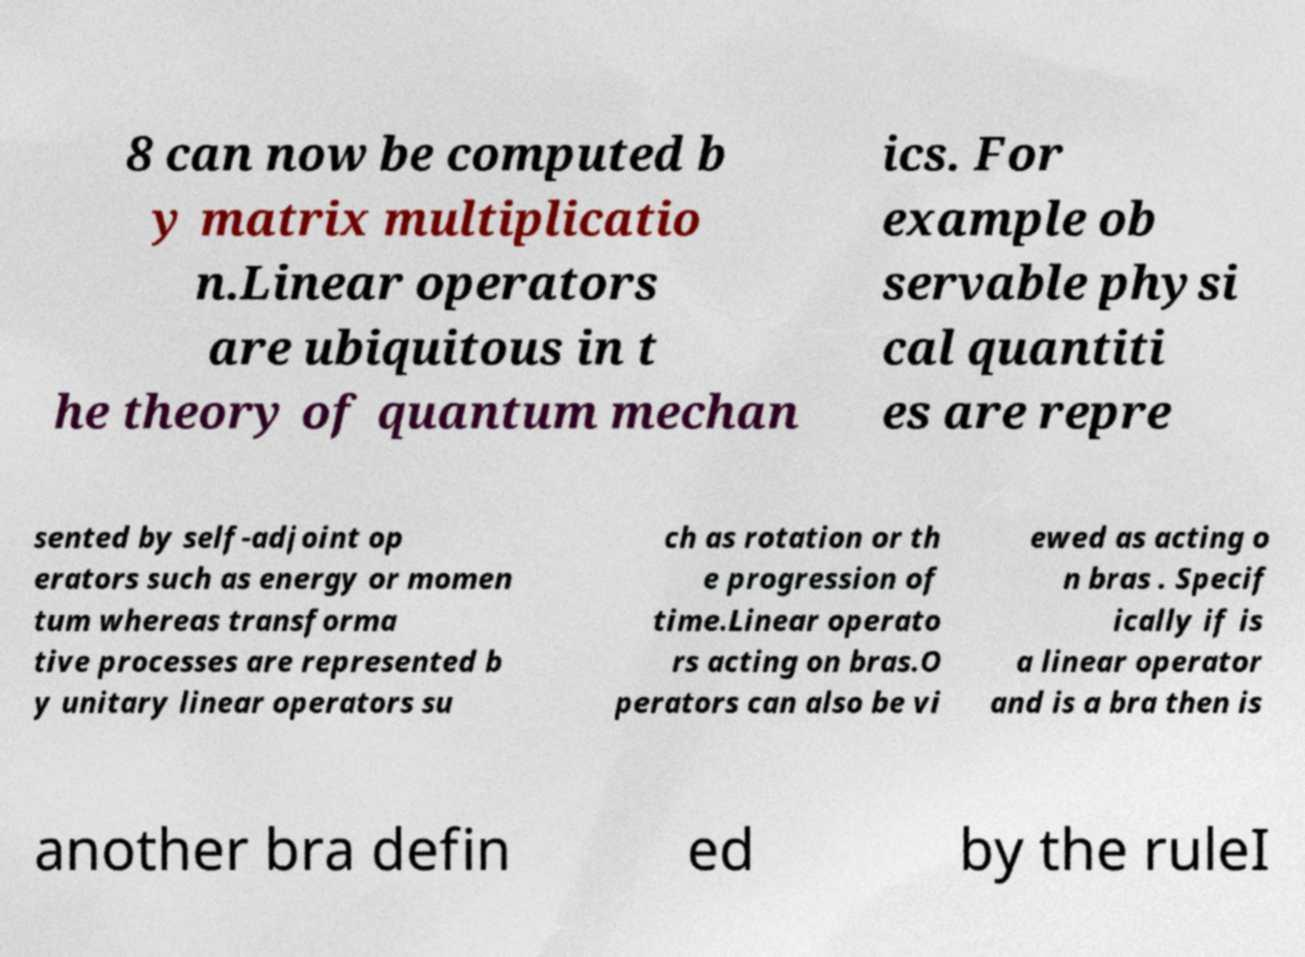Could you assist in decoding the text presented in this image and type it out clearly? 8 can now be computed b y matrix multiplicatio n.Linear operators are ubiquitous in t he theory of quantum mechan ics. For example ob servable physi cal quantiti es are repre sented by self-adjoint op erators such as energy or momen tum whereas transforma tive processes are represented b y unitary linear operators su ch as rotation or th e progression of time.Linear operato rs acting on bras.O perators can also be vi ewed as acting o n bras . Specif ically if is a linear operator and is a bra then is another bra defin ed by the ruleI 